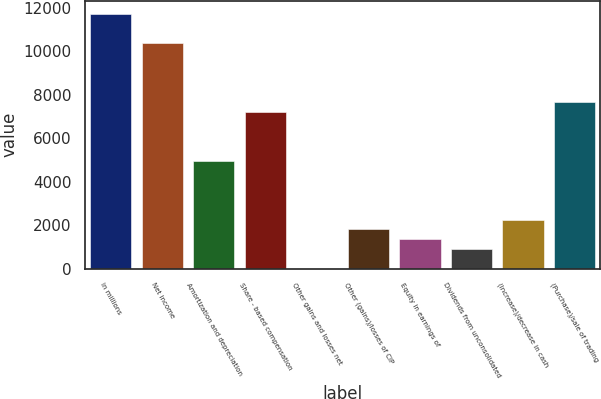Convert chart to OTSL. <chart><loc_0><loc_0><loc_500><loc_500><bar_chart><fcel>in millions<fcel>Net income<fcel>Amortization and depreciation<fcel>Share - based compensation<fcel>Other gains and losses net<fcel>Other (gains)/losses of CIP<fcel>Equity in earnings of<fcel>Dividends from unconsolidated<fcel>(Increase)/decrease in cash<fcel>(Purchase)/sale of trading<nl><fcel>11741.8<fcel>10387.1<fcel>4968.55<fcel>7226.3<fcel>1.5<fcel>1807.7<fcel>1356.15<fcel>904.6<fcel>2259.25<fcel>7677.85<nl></chart> 